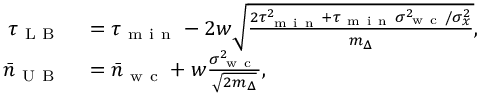<formula> <loc_0><loc_0><loc_500><loc_500>\begin{array} { r l } { \tau _ { L B } } & = \tau _ { m i n } - 2 w \sqrt { \frac { 2 \tau _ { m i n } ^ { 2 } + \tau _ { m i n } \sigma _ { w c } ^ { 2 } / \sigma _ { x } ^ { 2 } } { m _ { \Delta } } } , } \\ { \bar { n } _ { U B } } & = \bar { n } _ { w c } + w \frac { \sigma _ { w c } ^ { 2 } } { \sqrt { 2 m _ { \Delta } } } , } \end{array}</formula> 